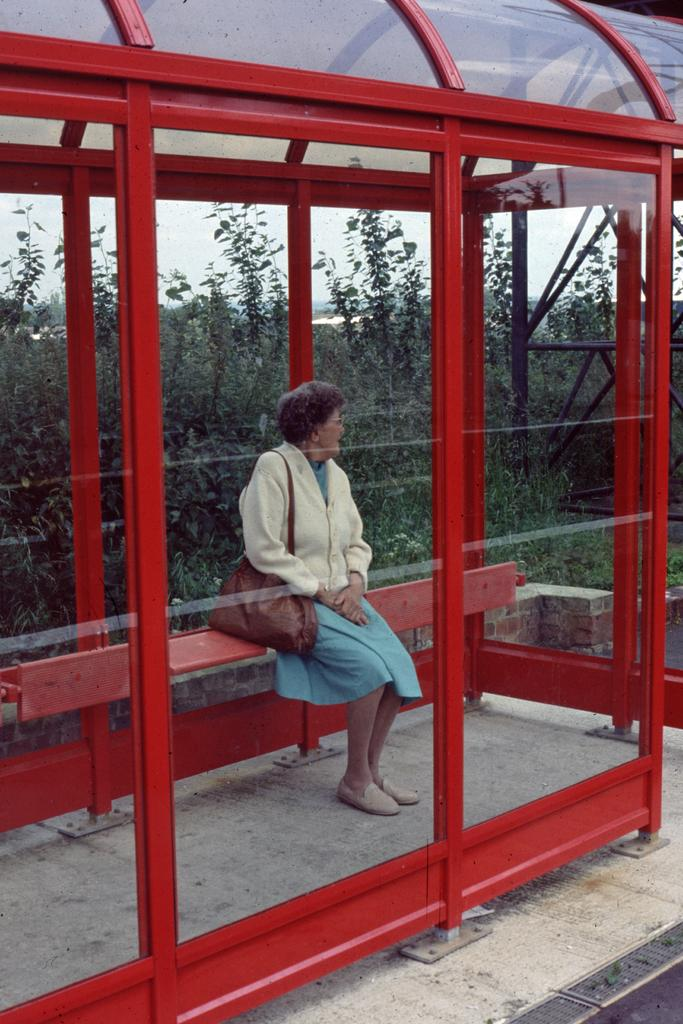What is the woman in the image doing? The woman is sitting on a bench in the image. Where is the bench located? The bench is located in a bus bay. What can be seen in the background of the image? Trees and the sky are visible in the image. What type of surface is visible in the image? There is a road and grass visible in the image. What type of brick is being used to invent a new square in the image? There is no mention of bricks, invention, or squares in the image. The image features a woman sitting on a bench in a bus bay, with trees, the sky, a road, and grass visible in the background. 